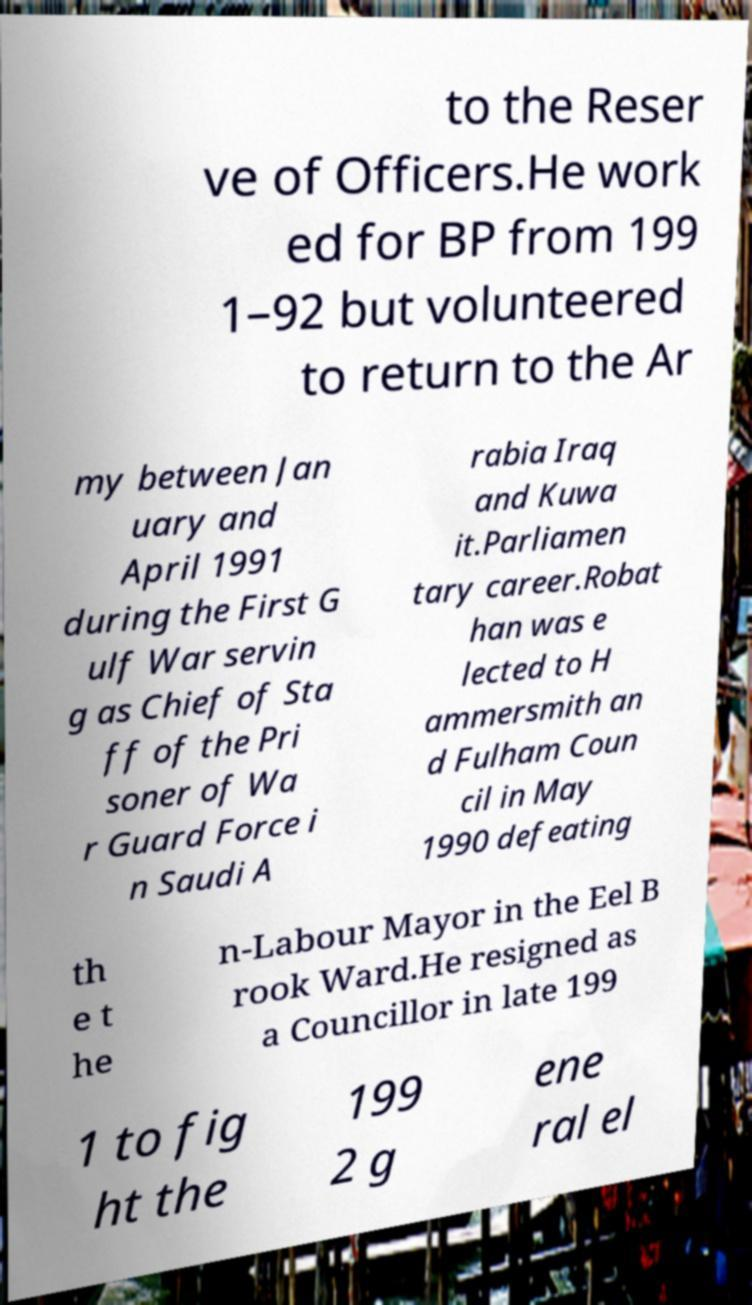I need the written content from this picture converted into text. Can you do that? to the Reser ve of Officers.He work ed for BP from 199 1–92 but volunteered to return to the Ar my between Jan uary and April 1991 during the First G ulf War servin g as Chief of Sta ff of the Pri soner of Wa r Guard Force i n Saudi A rabia Iraq and Kuwa it.Parliamen tary career.Robat han was e lected to H ammersmith an d Fulham Coun cil in May 1990 defeating th e t he n-Labour Mayor in the Eel B rook Ward.He resigned as a Councillor in late 199 1 to fig ht the 199 2 g ene ral el 